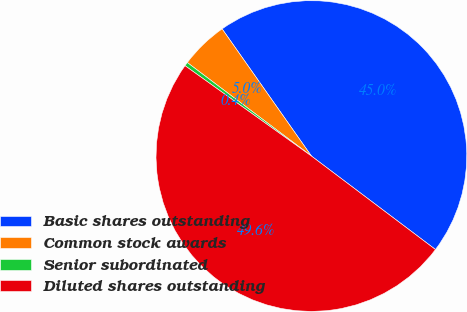<chart> <loc_0><loc_0><loc_500><loc_500><pie_chart><fcel>Basic shares outstanding<fcel>Common stock awards<fcel>Senior subordinated<fcel>Diluted shares outstanding<nl><fcel>45.02%<fcel>4.98%<fcel>0.4%<fcel>49.6%<nl></chart> 